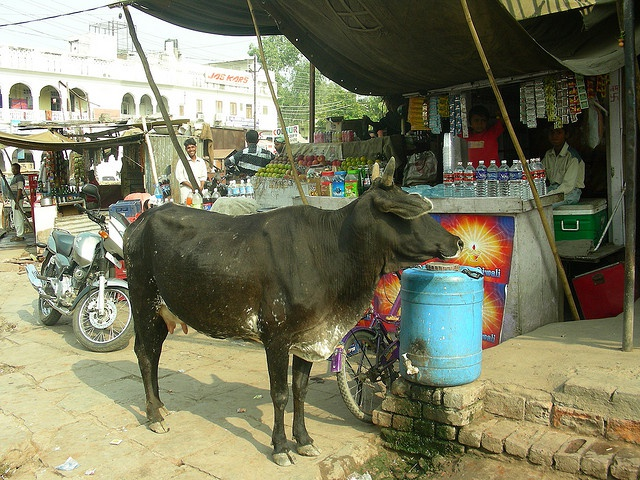Describe the objects in this image and their specific colors. I can see cow in white, black, darkgreen, gray, and olive tones, motorcycle in white, ivory, gray, and darkgray tones, bicycle in white, black, gray, darkgreen, and tan tones, people in white, black, gray, and darkgreen tones, and suitcase in white, maroon, black, gray, and darkgreen tones in this image. 